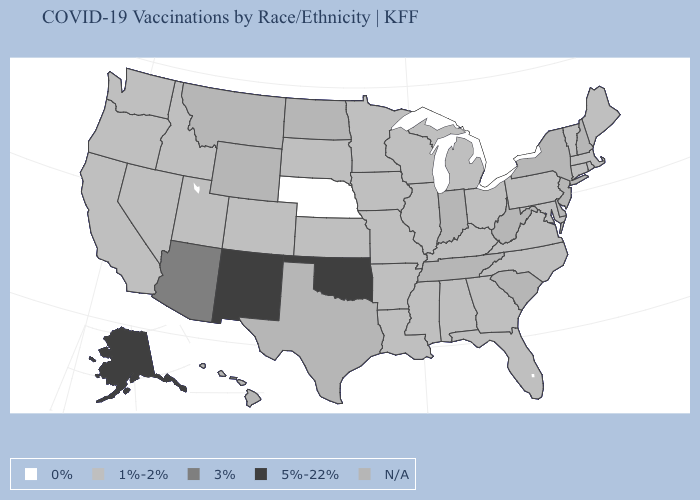Name the states that have a value in the range 1%-2%?
Give a very brief answer. Alabama, Arkansas, California, Colorado, Connecticut, Florida, Georgia, Idaho, Illinois, Iowa, Kansas, Kentucky, Louisiana, Maine, Maryland, Massachusetts, Michigan, Minnesota, Mississippi, Missouri, Nevada, North Carolina, Ohio, Oregon, Pennsylvania, Rhode Island, South Dakota, Utah, Vermont, Virginia, Washington, Wisconsin. What is the lowest value in states that border Wisconsin?
Give a very brief answer. 1%-2%. What is the value of West Virginia?
Answer briefly. N/A. What is the value of Alaska?
Short answer required. 5%-22%. What is the value of Utah?
Be succinct. 1%-2%. Name the states that have a value in the range 5%-22%?
Keep it brief. Alaska, New Mexico, Oklahoma. Does North Carolina have the lowest value in the South?
Be succinct. Yes. Name the states that have a value in the range 3%?
Quick response, please. Arizona. Does the map have missing data?
Answer briefly. Yes. Name the states that have a value in the range 0%?
Short answer required. Nebraska. Which states hav the highest value in the West?
Be succinct. Alaska, New Mexico. Name the states that have a value in the range 3%?
Concise answer only. Arizona. Does the map have missing data?
Keep it brief. Yes. 